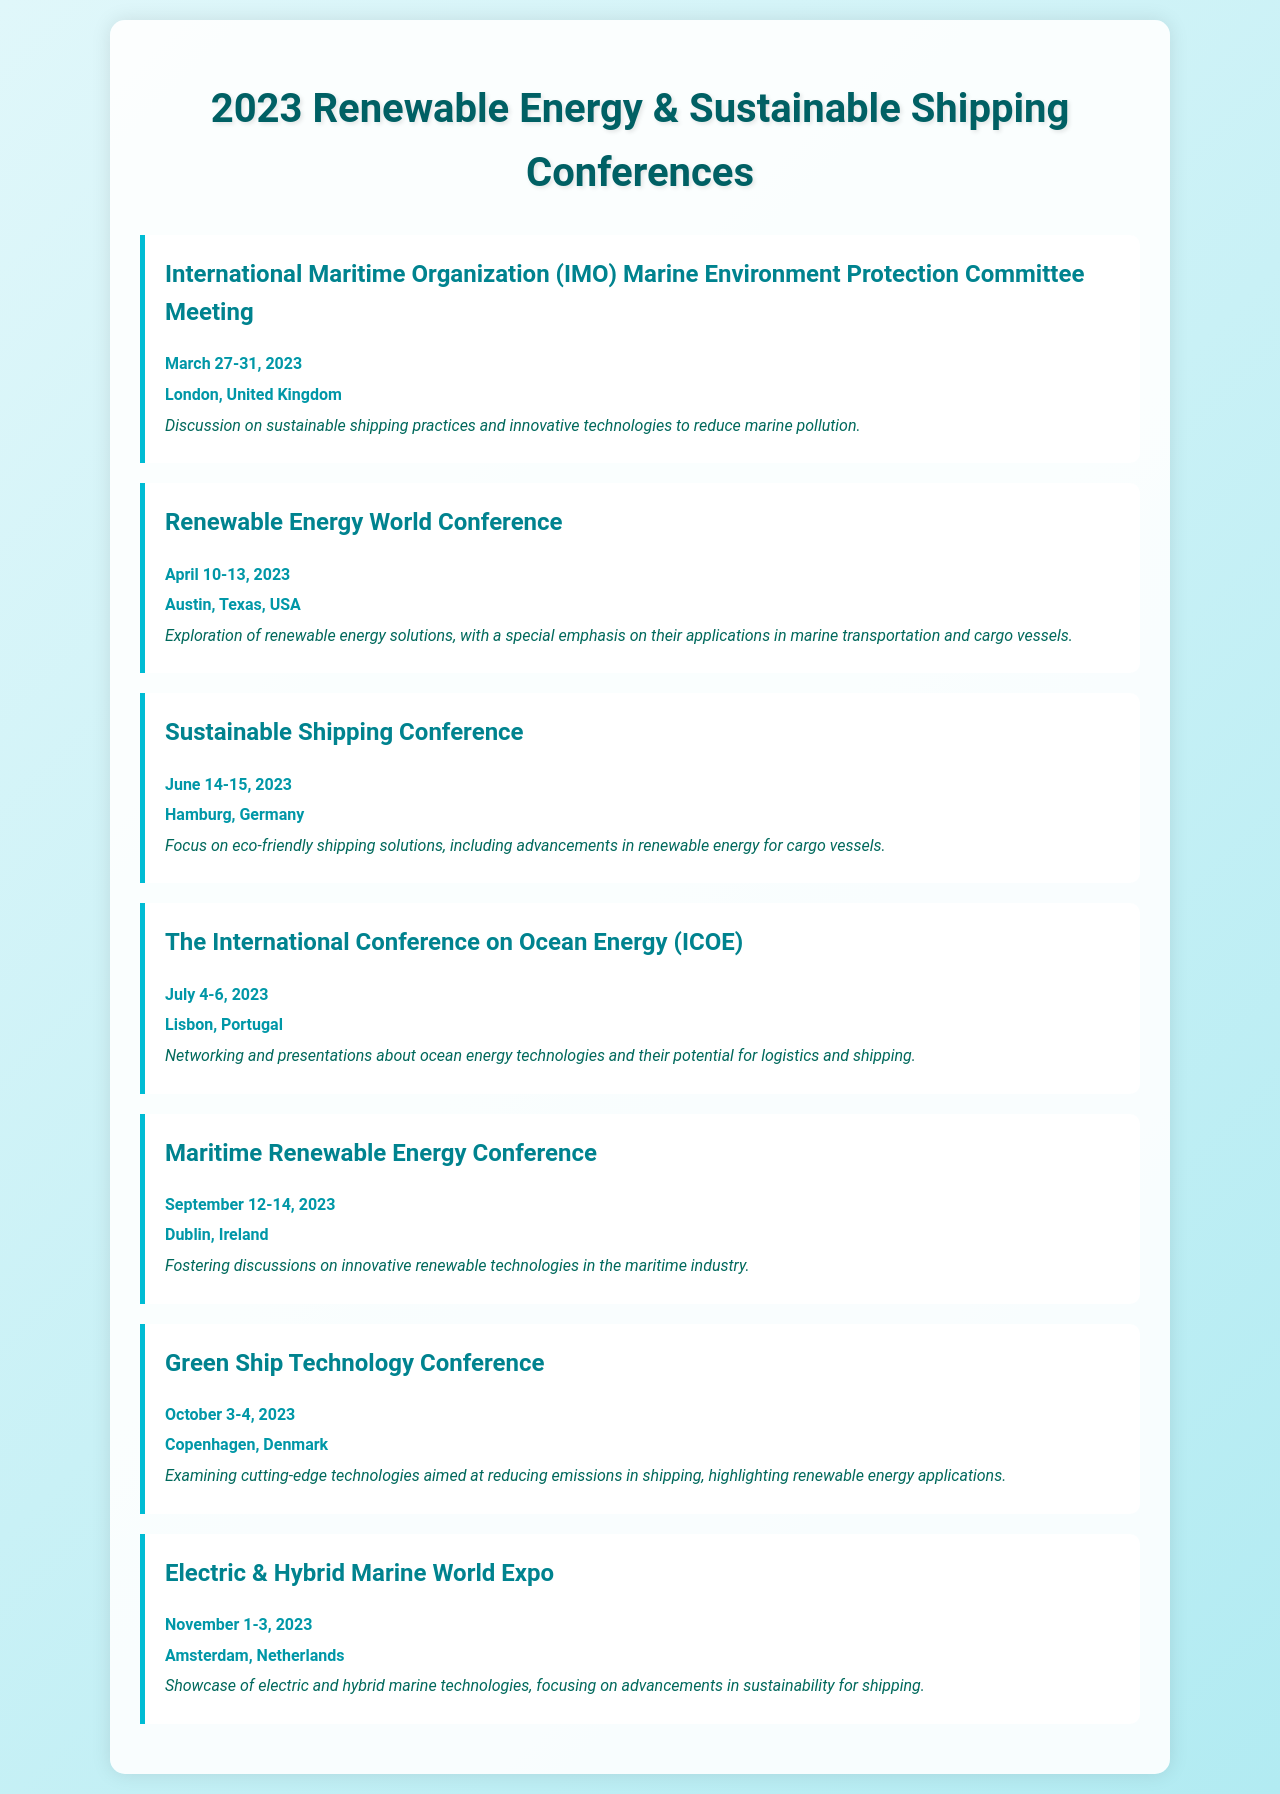What is the date of the Renewable Energy World Conference? The date of the Renewable Energy World Conference is found in the document and is specified as April 10-13, 2023.
Answer: April 10-13, 2023 Where is the Maritime Renewable Energy Conference held? The location of the Maritime Renewable Energy Conference is indicated in the conference details in the document.
Answer: Dublin, Ireland Which conference focuses on electric and hybrid marine technologies? The document lists multiple conferences, the one focusing on electric and hybrid marine technologies is specifically identified.
Answer: Electric & Hybrid Marine World Expo What is the primary focus of the Sustainable Shipping Conference? The document contains a brief description of the Sustainable Shipping Conference's focus area related to eco-friendly solutions.
Answer: Eco-friendly shipping solutions How many days does the International Maritime Organization meeting last? The duration of the International Maritime Organization meeting can be calculated by the dates given in the document.
Answer: 5 days What is the last conference listed in the document? The last conference mentioned in the document corresponds to its chronological position within the list.
Answer: Electric & Hybrid Marine World Expo Which city hosts the Green Ship Technology Conference? The city hosting the Green Ship Technology Conference is explicitly stated in the document.
Answer: Copenhagen When is the International Conference on Ocean Energy scheduled? The date of the International Conference on Ocean Energy is provided and can be directly retrieved from the document.
Answer: July 4-6, 2023 